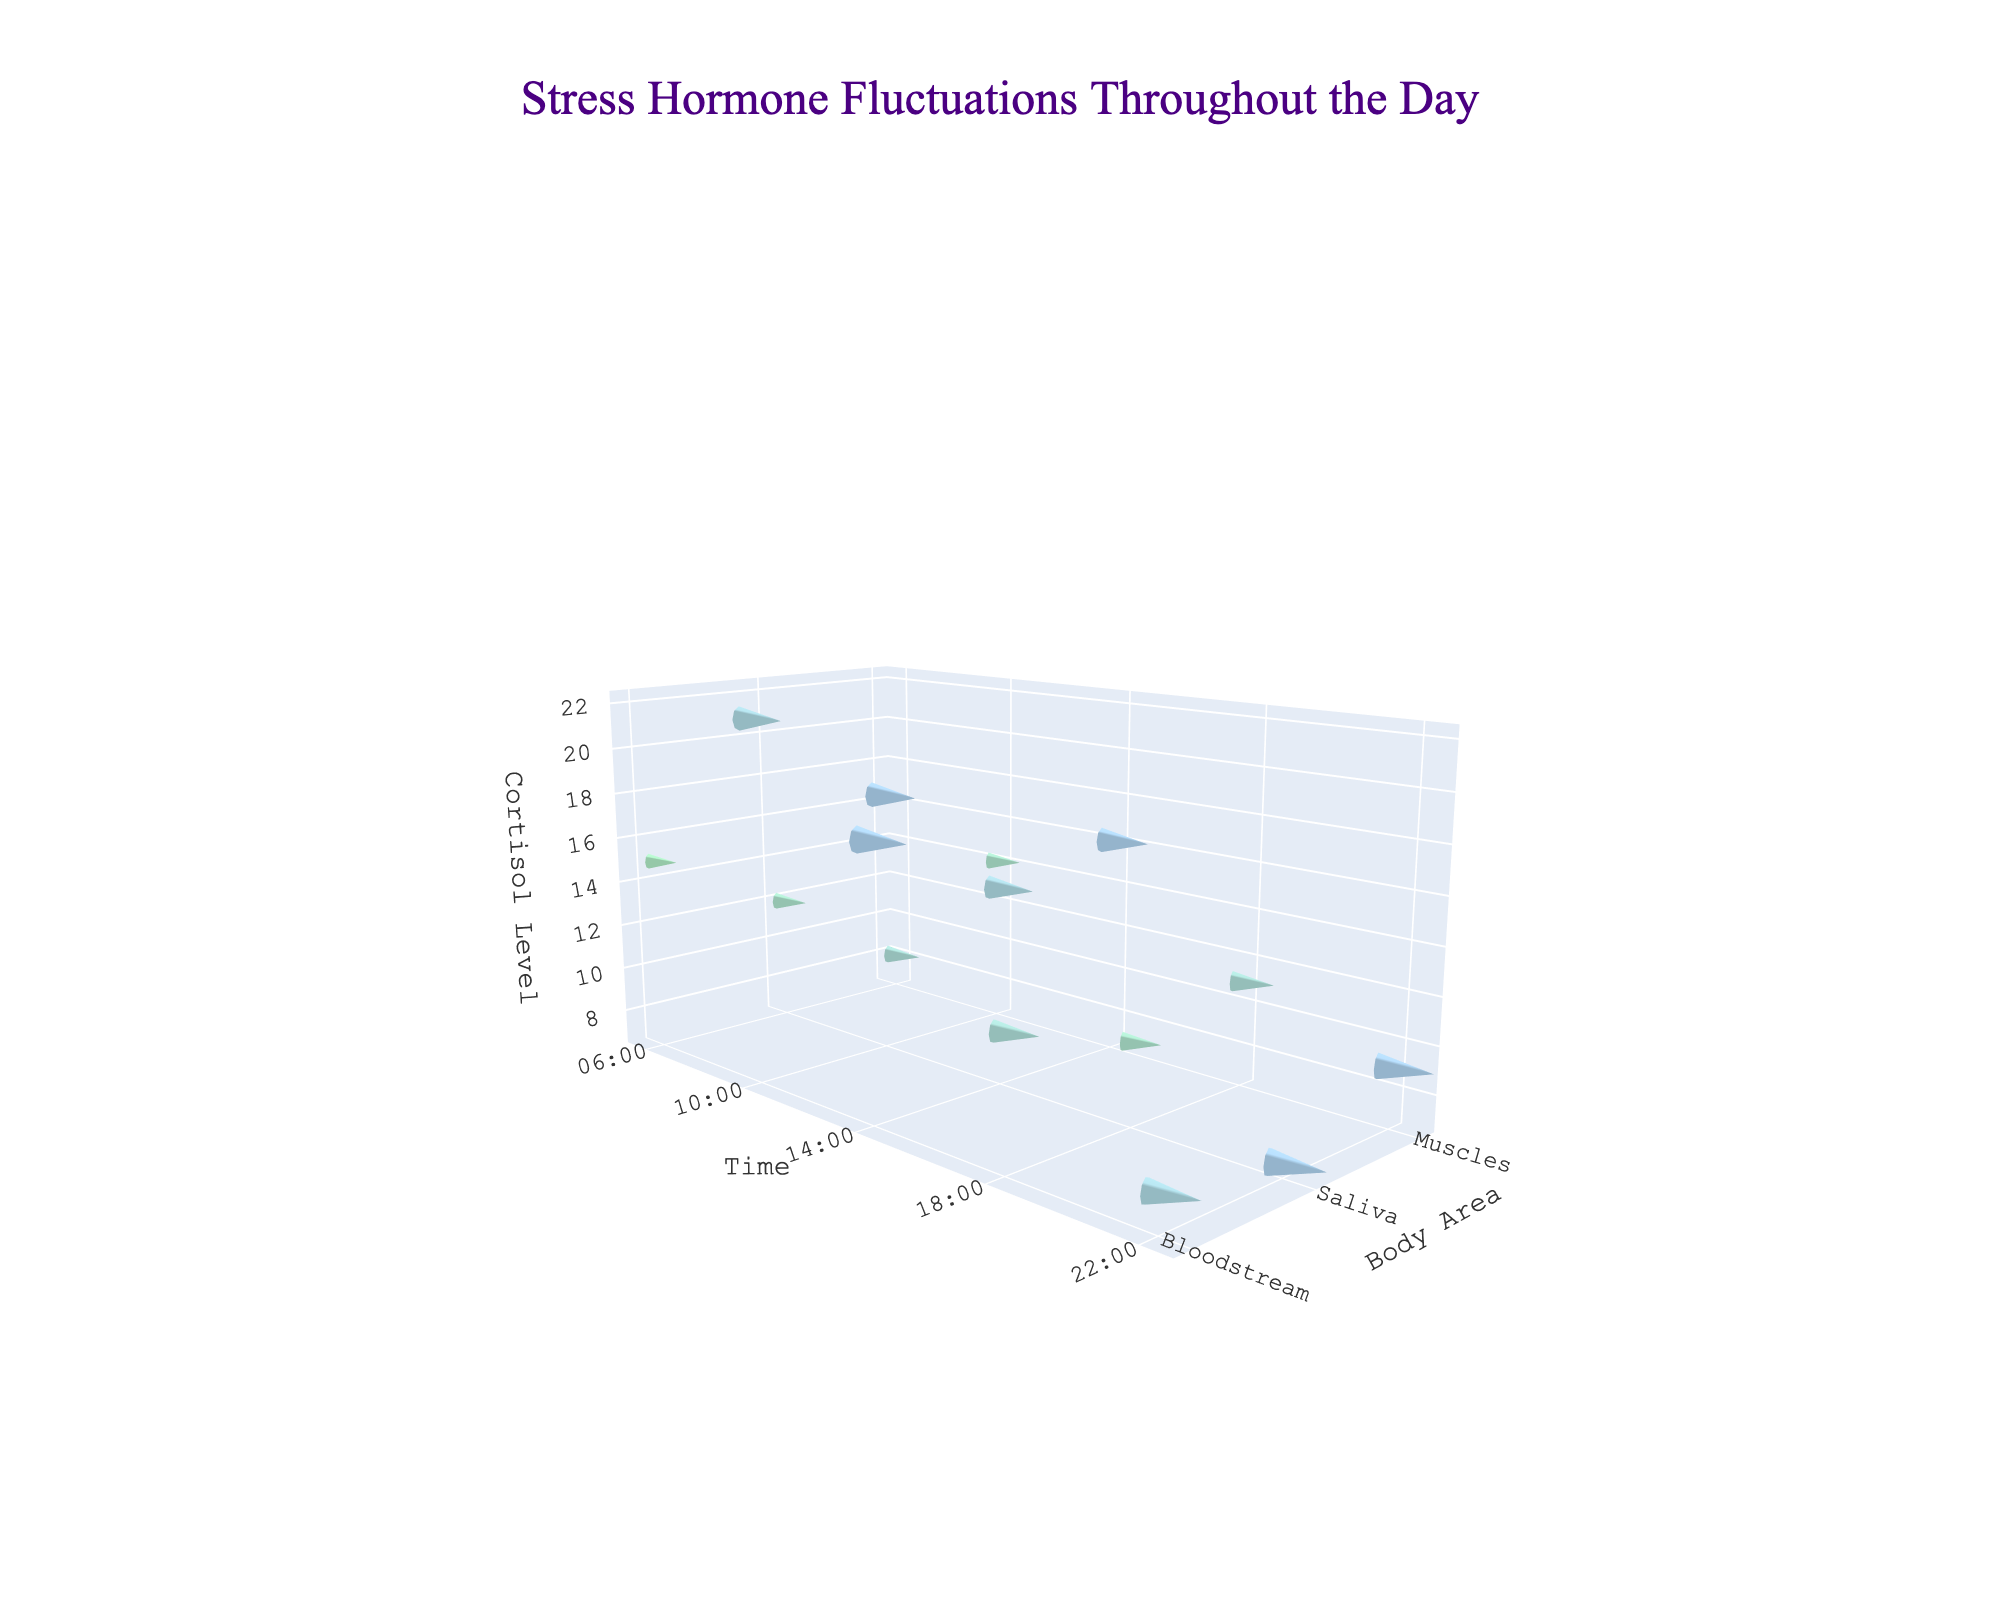What is the title of the plot? The title is usually placed at the top of the plot, written in a larger font size compared to other text. Looking at the top center of this figure, you will find the title written as "Stress Hormone Fluctuations Throughout the Day".
Answer: Stress Hormone Fluctuations Throughout the Day What are the body areas tracked in this plot? In a quiver plot, body areas are categorized along the y-axis. From the y-axis labels, we can see the different body areas tracked: Bloodstream, Saliva, and Muscles.
Answer: Bloodstream, Saliva, Muscles At which time is the cortisol level in the Bloodstream highest? Cortisol levels are plotted along the z-axis, and the respective times are on the x-axis. Observing the highest z-axis point for the Bloodstream, it peaks at 10:00 with a value of 22.
Answer: 10:00 How do the changes in cortisol levels differ between Bloodstream and Saliva at 06:00? Compare the ChangeDirection and ChangeIntensity vectors for 06:00; in the Bloodstream, it has a direction of 1 and an intensity of 3, while in Saliva, it has a direction of 1 and an intensity of 2. This means the Bloodstream has a larger upward change than Saliva at this time.
Answer: Bloodstream: 3 units up, Saliva: 2 units up Which body area shows the most consistent change direction (either positive or negative) throughout the day? Examine the vector directions (ChangeDirection) for each body area across all time points. The Muscles area shows consistent changes primarily in the positive direction (increasing direction) at 06:00, 10:00, and 18:00.
Answer: Muscles What time sees the largest overall decrease in cortisol levels in the Bloodstream? Look at the magnitude of negative values for ChangeIntensity and ChangeDirection multiplied together in the Bloodstream. The largest decrease occurs at 10:00, with a value of -2, which appears larger than the decrease observed at other times.
Answer: 10:00 What pattern can be observed in cortisol level changes in Saliva between 14:00 and 18:00? Analyze the figures' quiver vectors specifically for Saliva at these times. At 14:00, there is a downward change (direction -1, intensity 2), and at 18:00, there's an upward change (direction 1, intensity 2). This indicates a reduction followed by an increase in cortisol levels in Saliva between these two times.
Answer: Decrease at 14:00, increase at 18:00 Which time period shows the least amount of change for cortisol levels in Muscles? By evaluating the length of the vectors (ChangeIntensity) in Muscles throughout the day, the smallest changes are observed at 06:00 and 14:00, showing an intensity of 1 unit. But 22:00 also shows a minimal change with -1 unit.
Answer: 22:00 What is the prevalent trend in cortisol levels in the Bloodstream from 06:00 to 22:00? Examine the vectors' directions and intensities from 06:00 to 22:00: starting with an upward change (06:00), significant decline (10:00), another moderate decline (14:00), small increase (18:00), and final notable decrease (22:00). The overall trend is a significant decrease in cortisol levels throughout the day.
Answer: Decreasing trend 